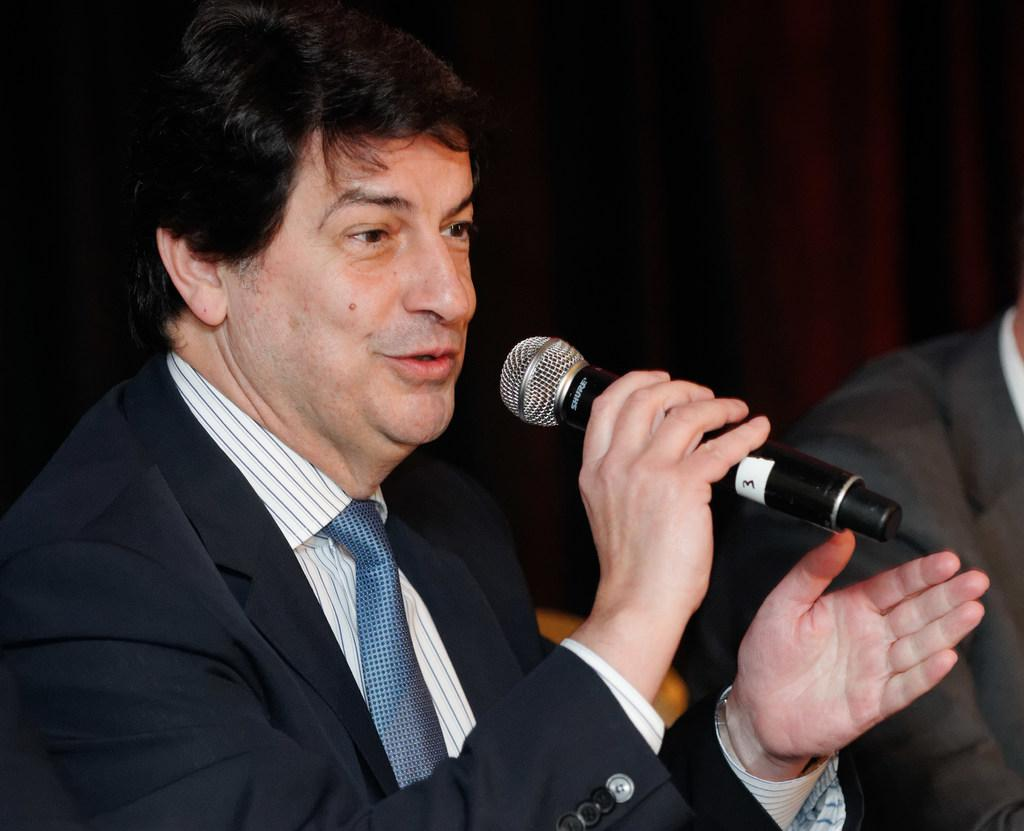What is the person holding a mic doing in the image? The person holding a mic is likely speaking or performing. How is the person holding a mic dressed? The person holding a mic is wearing a black suit and tie. Is there anyone else in the image with the person holding a mic? Yes, there is another person in a black suit beside the first person. What type of texture can be seen on the stove in the image? There is no stove present in the image. What type of food is being prepared on the stove in the image? There is no stove or food present in the image. 